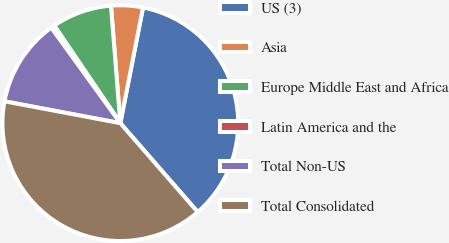Convert chart. <chart><loc_0><loc_0><loc_500><loc_500><pie_chart><fcel>US (3)<fcel>Asia<fcel>Europe Middle East and Africa<fcel>Latin America and the<fcel>Total Non-US<fcel>Total Consolidated<nl><fcel>35.51%<fcel>4.35%<fcel>8.21%<fcel>0.49%<fcel>12.07%<fcel>39.37%<nl></chart> 